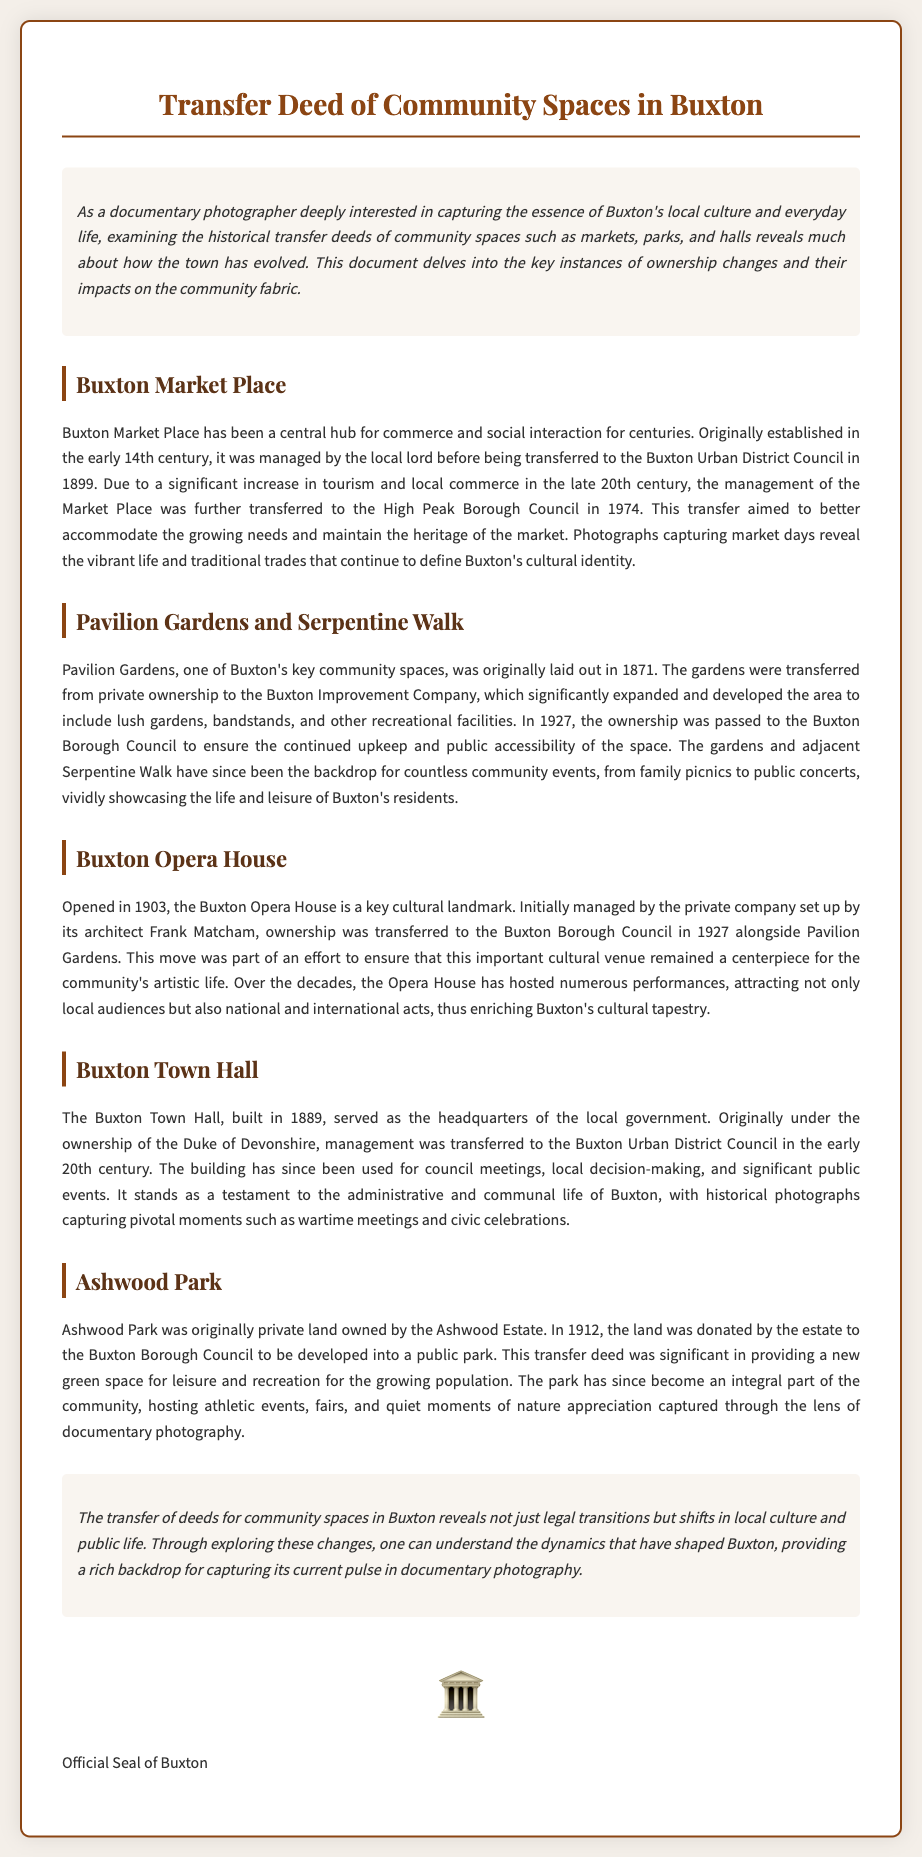What year was Buxton Market Place transferred to the Buxton Urban District Council? The document states that Buxton Market Place was transferred in 1899.
Answer: 1899 What year was Pavilion Gardens transferred to the Buxton Borough Council? According to the document, Pavilion Gardens was transferred in 1927.
Answer: 1927 Who was the architect of the Buxton Opera House? The document mentions that the architect of the Buxton Opera House was Frank Matcham.
Answer: Frank Matcham What type of venue is the Buxton Opera House? The Buxton Opera House is identified as a cultural landmark.
Answer: Cultural landmark How many years after its opening did the Buxton Opera House transfer ownership to the Buxton Borough Council? The Buxton Opera House opened in 1903 and transferred ownership in 1927, which is 24 years later.
Answer: 24 years What was the original purpose of Ashwood Park land before it was donated? The document states that Ashwood Park was originally private land owned by the Ashwood Estate.
Answer: Private land What other community space was transferred alongside the Buxton Opera House in 1927? The document indicates that Pavilion Gardens was transferred alongside the Buxton Opera House.
Answer: Pavilion Gardens How did the transfer of community spaces affect Buxton's local culture and public life? The document notes that the transfer reveals shifts in local culture and public life.
Answer: Shifts in local culture and public life 